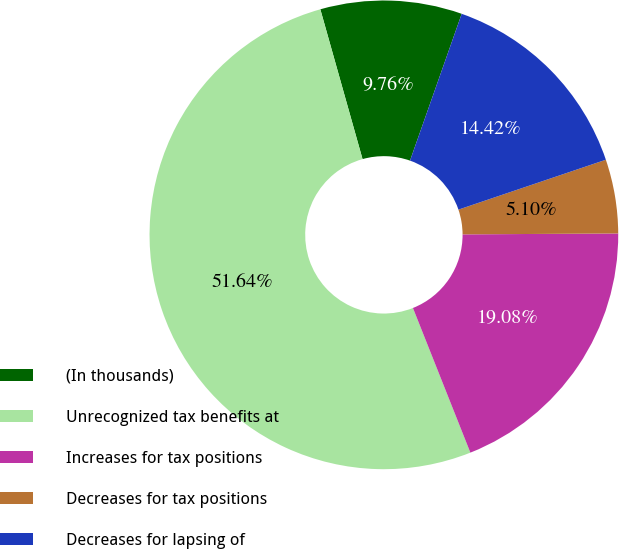Convert chart to OTSL. <chart><loc_0><loc_0><loc_500><loc_500><pie_chart><fcel>(In thousands)<fcel>Unrecognized tax benefits at<fcel>Increases for tax positions<fcel>Decreases for tax positions<fcel>Decreases for lapsing of<nl><fcel>9.76%<fcel>51.65%<fcel>19.08%<fcel>5.1%<fcel>14.42%<nl></chart> 